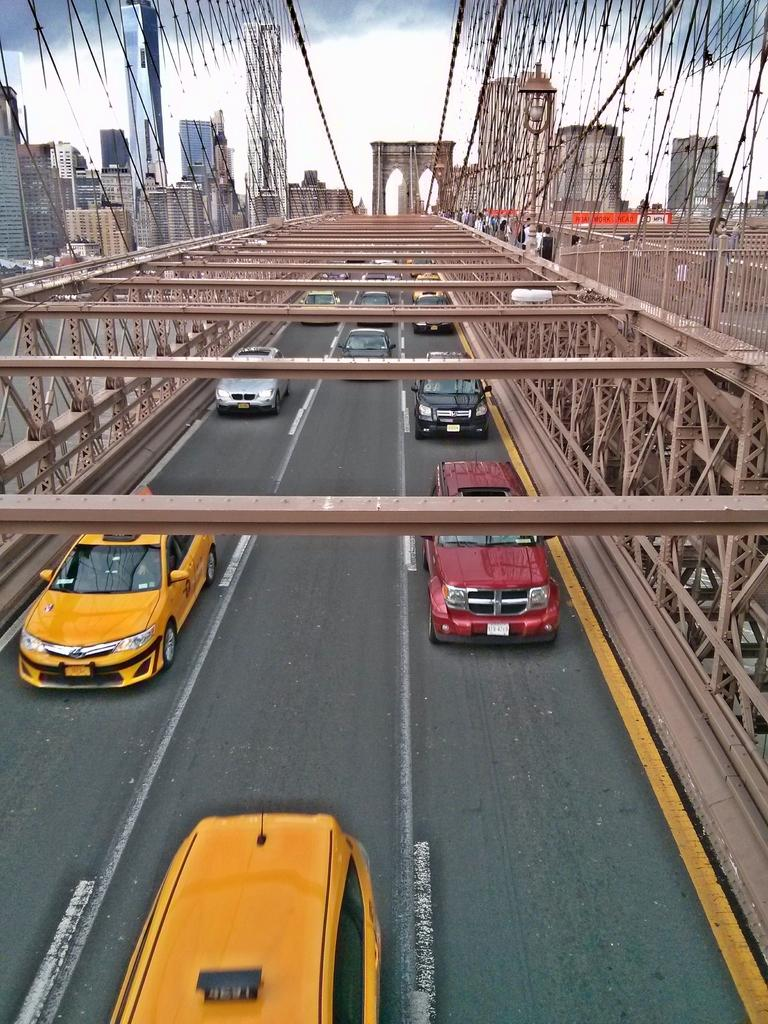What can be seen on the road in the image? There are vehicles on the road in the image. What type of structures are visible in the image? There are buildings in the image. What material are the rods made of in the image? Metal rods are present in the image. What is visible in the background of the image? The sky is visible in the background of the image. What can be observed in the sky in the image? Clouds are present in the sky. How many brothers are playing the game with the duck in the image? There are no brothers, game, or duck present in the image. 